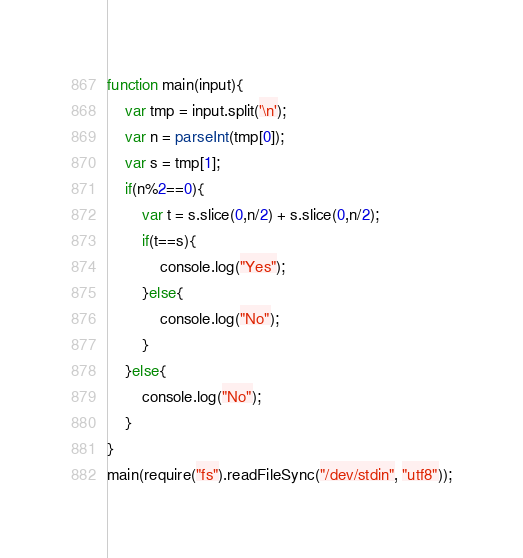<code> <loc_0><loc_0><loc_500><loc_500><_JavaScript_>function main(input){
    var tmp = input.split('\n');
    var n = parseInt(tmp[0]);
    var s = tmp[1];
    if(n%2==0){
        var t = s.slice(0,n/2) + s.slice(0,n/2);
        if(t==s){
            console.log("Yes");
        }else{
            console.log("No");
        }
    }else{
        console.log("No");
    }
}
main(require("fs").readFileSync("/dev/stdin", "utf8"));</code> 